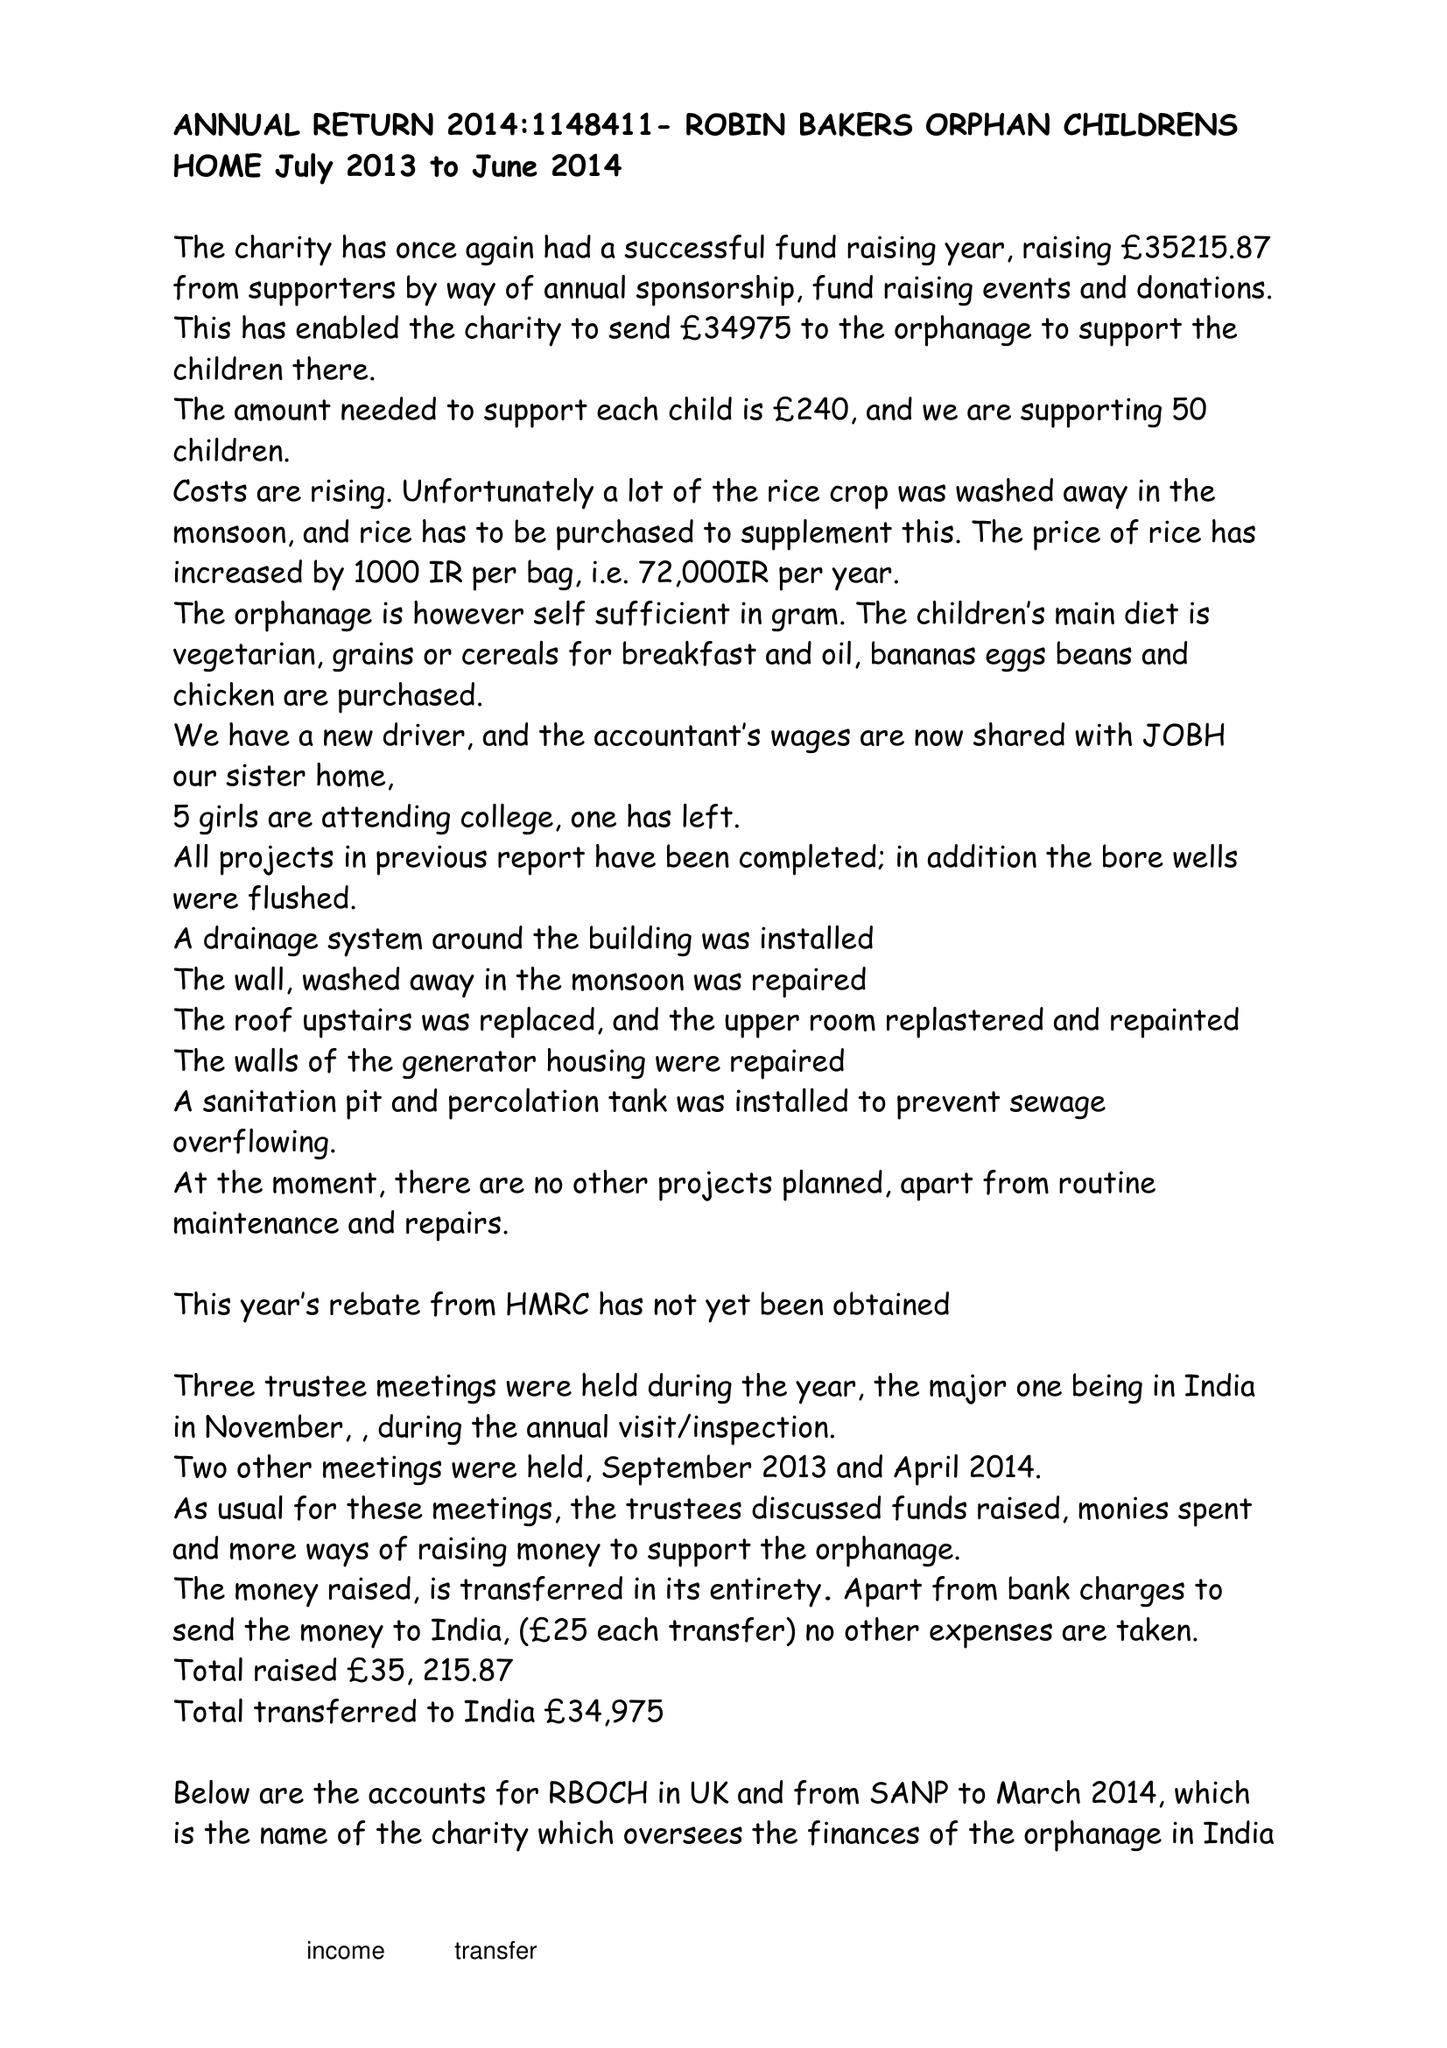What is the value for the address__postcode?
Answer the question using a single word or phrase. BS40 6ES 